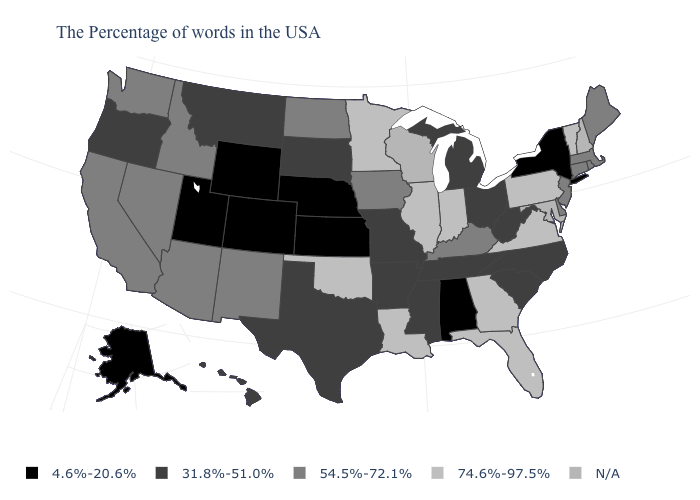What is the value of South Carolina?
Keep it brief. 31.8%-51.0%. Is the legend a continuous bar?
Short answer required. No. What is the value of Oregon?
Quick response, please. 31.8%-51.0%. Among the states that border Maryland , does West Virginia have the lowest value?
Quick response, please. Yes. Which states hav the highest value in the West?
Give a very brief answer. New Mexico, Arizona, Idaho, Nevada, California, Washington. What is the value of Colorado?
Short answer required. 4.6%-20.6%. Which states have the lowest value in the MidWest?
Keep it brief. Kansas, Nebraska. Which states have the lowest value in the MidWest?
Answer briefly. Kansas, Nebraska. What is the value of North Carolina?
Write a very short answer. 31.8%-51.0%. Name the states that have a value in the range 4.6%-20.6%?
Give a very brief answer. New York, Alabama, Kansas, Nebraska, Wyoming, Colorado, Utah, Alaska. Name the states that have a value in the range 31.8%-51.0%?
Quick response, please. North Carolina, South Carolina, West Virginia, Ohio, Michigan, Tennessee, Mississippi, Missouri, Arkansas, Texas, South Dakota, Montana, Oregon, Hawaii. What is the value of Georgia?
Concise answer only. 74.6%-97.5%. Name the states that have a value in the range 54.5%-72.1%?
Short answer required. Maine, Massachusetts, Rhode Island, Connecticut, New Jersey, Delaware, Kentucky, Iowa, North Dakota, New Mexico, Arizona, Idaho, Nevada, California, Washington. Does Wyoming have the lowest value in the USA?
Write a very short answer. Yes. 